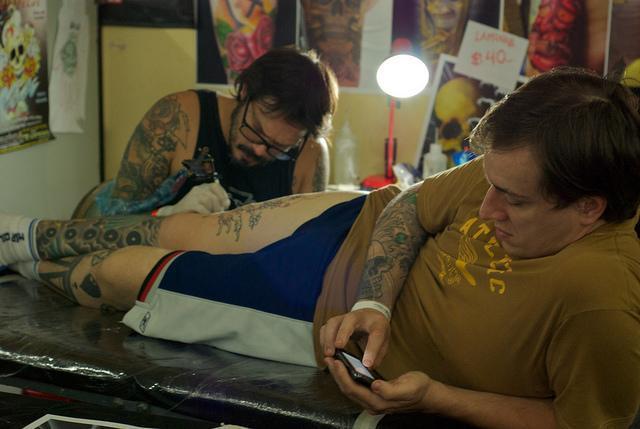How many people are there?
Give a very brief answer. 2. 